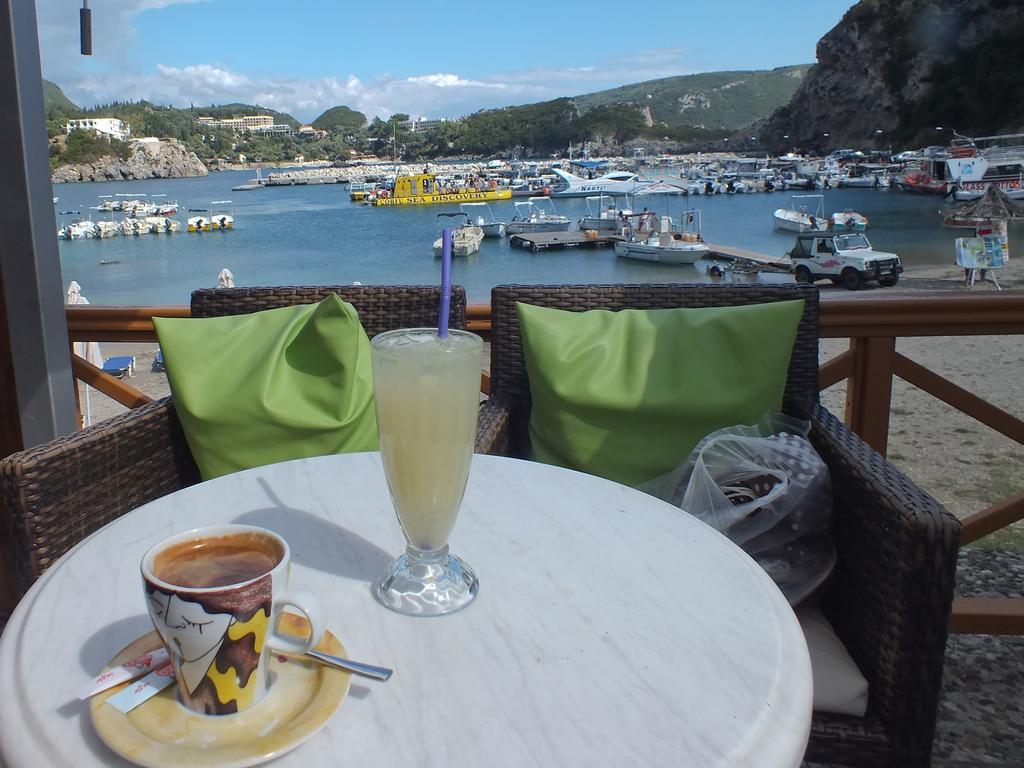Could you give a brief overview of what you see in this image? In this picture We can see two chairs and a table, there are two pillows on the chairs there is drink in the glass on table and also we can see a cup, in the background we can see some water and there is a beach here, there are number of boats on the water, in the background we can see you building and we can also see trees and sky on the right side of the image and see some hills, here we can see a vehicle standing on the banks of water. 